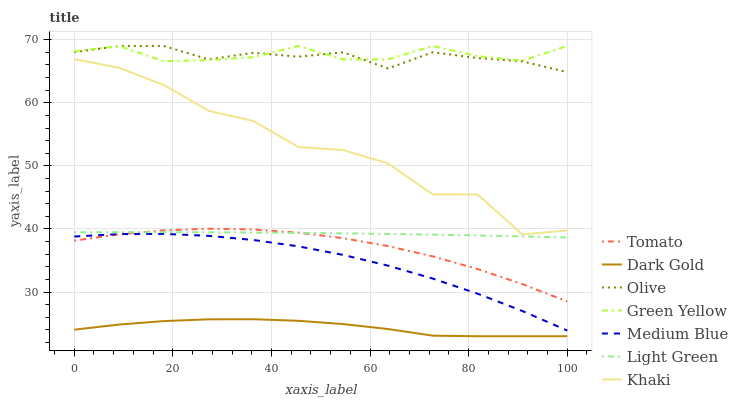Does Dark Gold have the minimum area under the curve?
Answer yes or no. Yes. Does Green Yellow have the maximum area under the curve?
Answer yes or no. Yes. Does Khaki have the minimum area under the curve?
Answer yes or no. No. Does Khaki have the maximum area under the curve?
Answer yes or no. No. Is Light Green the smoothest?
Answer yes or no. Yes. Is Khaki the roughest?
Answer yes or no. Yes. Is Dark Gold the smoothest?
Answer yes or no. No. Is Dark Gold the roughest?
Answer yes or no. No. Does Dark Gold have the lowest value?
Answer yes or no. Yes. Does Khaki have the lowest value?
Answer yes or no. No. Does Green Yellow have the highest value?
Answer yes or no. Yes. Does Khaki have the highest value?
Answer yes or no. No. Is Dark Gold less than Light Green?
Answer yes or no. Yes. Is Green Yellow greater than Dark Gold?
Answer yes or no. Yes. Does Medium Blue intersect Tomato?
Answer yes or no. Yes. Is Medium Blue less than Tomato?
Answer yes or no. No. Is Medium Blue greater than Tomato?
Answer yes or no. No. Does Dark Gold intersect Light Green?
Answer yes or no. No. 